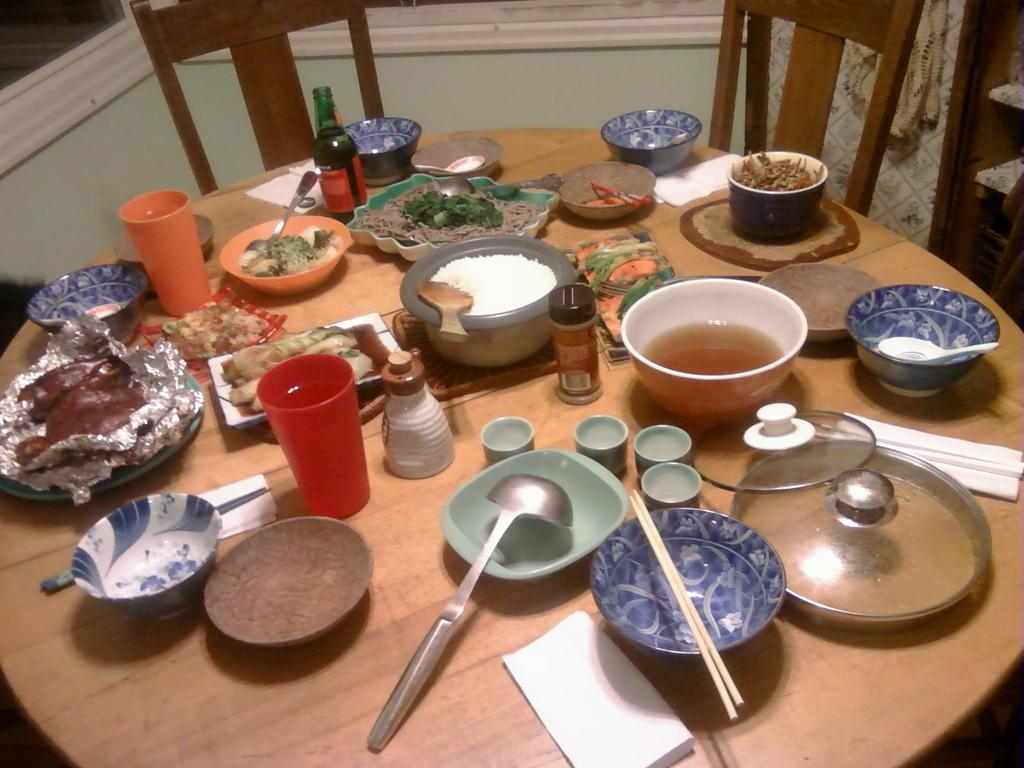What is located in the middle of the image? There is a table in the middle of the image. What can be found on the table? There are bowls, chopsticks, spoons, a cup, and a bottle on the table. What might be used for eating the contents of the bowls? Chopsticks and spoons are present on the table for eating. How are people able to sit around the table? There are chairs surrounding the table. How many eyes can be seen on the bun in the image? There is no bun present in the image, and therefore no eyes can be seen on it. 